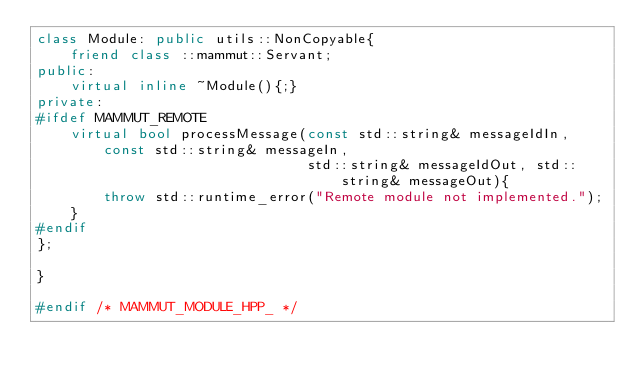Convert code to text. <code><loc_0><loc_0><loc_500><loc_500><_C++_>class Module: public utils::NonCopyable{
    friend class ::mammut::Servant;
public:
    virtual inline ~Module(){;}
private:
#ifdef MAMMUT_REMOTE
    virtual bool processMessage(const std::string& messageIdIn, const std::string& messageIn,
                                std::string& messageIdOut, std::string& messageOut){
        throw std::runtime_error("Remote module not implemented.");
    }
#endif
};

}

#endif /* MAMMUT_MODULE_HPP_ */
</code> 